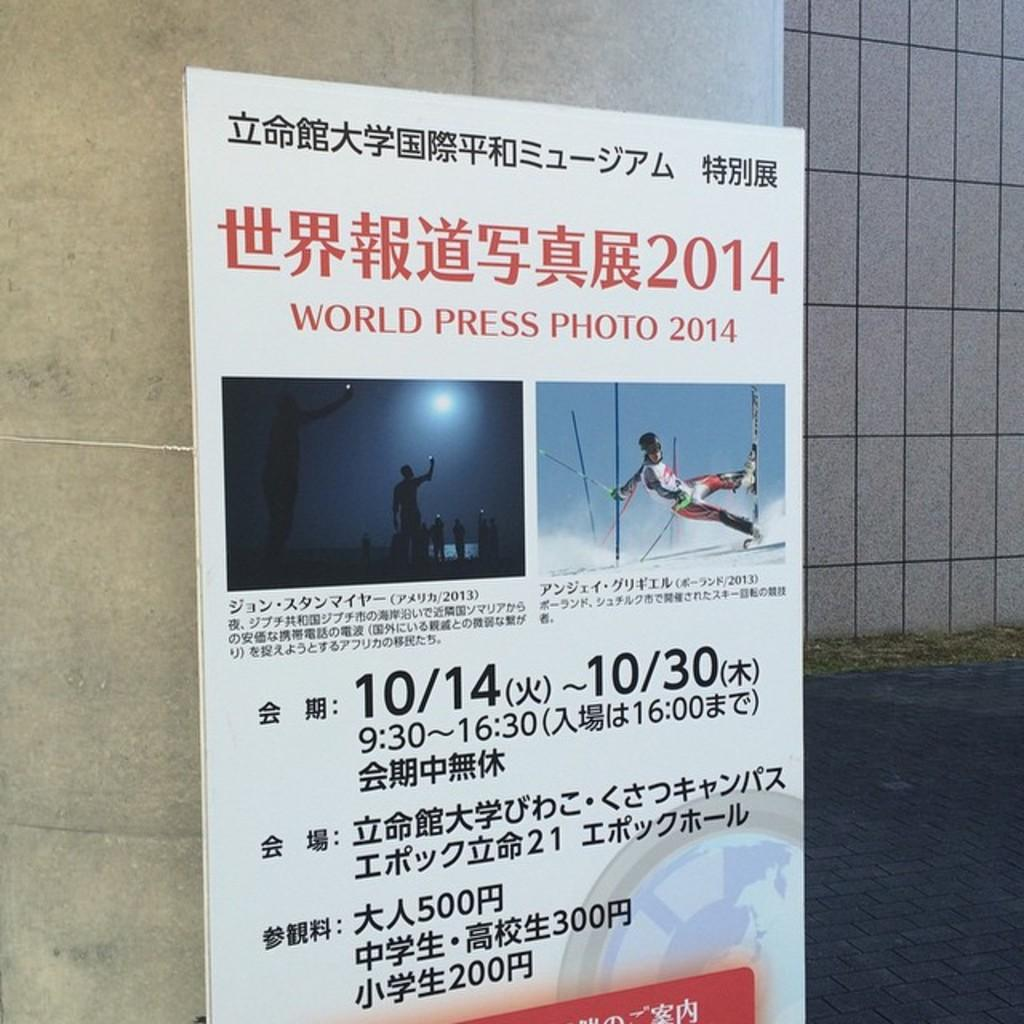<image>
Relay a brief, clear account of the picture shown. A poster that says World Press Photo 201 